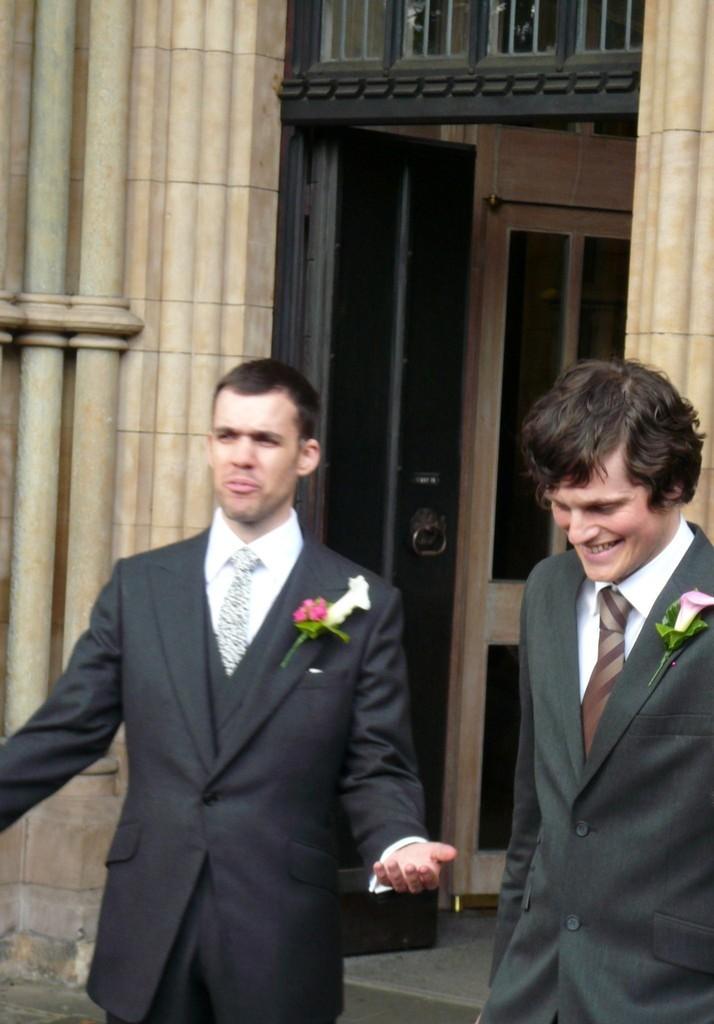Can you describe this image briefly? In this image we can see two persons wearing a coat and tie are standing on the floor. Two flowers are placed on the coats. In the background we can see a building with poles, door and a window. 